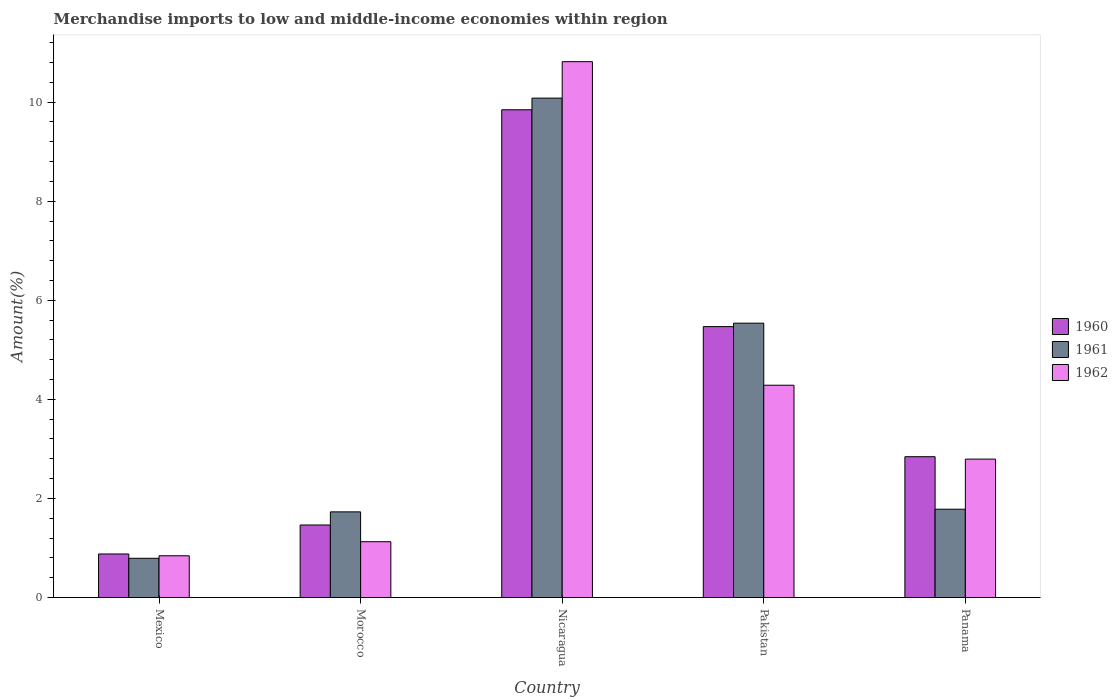How many different coloured bars are there?
Your answer should be very brief. 3. Are the number of bars per tick equal to the number of legend labels?
Offer a terse response. Yes. What is the label of the 1st group of bars from the left?
Provide a short and direct response. Mexico. In how many cases, is the number of bars for a given country not equal to the number of legend labels?
Keep it short and to the point. 0. What is the percentage of amount earned from merchandise imports in 1962 in Morocco?
Keep it short and to the point. 1.13. Across all countries, what is the maximum percentage of amount earned from merchandise imports in 1961?
Ensure brevity in your answer.  10.08. Across all countries, what is the minimum percentage of amount earned from merchandise imports in 1960?
Ensure brevity in your answer.  0.88. In which country was the percentage of amount earned from merchandise imports in 1960 maximum?
Your answer should be compact. Nicaragua. In which country was the percentage of amount earned from merchandise imports in 1962 minimum?
Offer a terse response. Mexico. What is the total percentage of amount earned from merchandise imports in 1962 in the graph?
Ensure brevity in your answer.  19.86. What is the difference between the percentage of amount earned from merchandise imports in 1961 in Morocco and that in Panama?
Keep it short and to the point. -0.05. What is the difference between the percentage of amount earned from merchandise imports in 1960 in Panama and the percentage of amount earned from merchandise imports in 1962 in Mexico?
Provide a short and direct response. 2. What is the average percentage of amount earned from merchandise imports in 1960 per country?
Keep it short and to the point. 4.1. What is the difference between the percentage of amount earned from merchandise imports of/in 1962 and percentage of amount earned from merchandise imports of/in 1960 in Mexico?
Provide a succinct answer. -0.04. What is the ratio of the percentage of amount earned from merchandise imports in 1961 in Nicaragua to that in Panama?
Ensure brevity in your answer.  5.66. What is the difference between the highest and the second highest percentage of amount earned from merchandise imports in 1961?
Keep it short and to the point. -8.3. What is the difference between the highest and the lowest percentage of amount earned from merchandise imports in 1961?
Make the answer very short. 9.29. In how many countries, is the percentage of amount earned from merchandise imports in 1961 greater than the average percentage of amount earned from merchandise imports in 1961 taken over all countries?
Provide a short and direct response. 2. Is the sum of the percentage of amount earned from merchandise imports in 1961 in Nicaragua and Pakistan greater than the maximum percentage of amount earned from merchandise imports in 1962 across all countries?
Your answer should be very brief. Yes. What does the 2nd bar from the left in Mexico represents?
Give a very brief answer. 1961. What does the 2nd bar from the right in Panama represents?
Your answer should be very brief. 1961. Does the graph contain any zero values?
Your response must be concise. No. Where does the legend appear in the graph?
Ensure brevity in your answer.  Center right. How many legend labels are there?
Keep it short and to the point. 3. How are the legend labels stacked?
Ensure brevity in your answer.  Vertical. What is the title of the graph?
Your answer should be compact. Merchandise imports to low and middle-income economies within region. What is the label or title of the X-axis?
Your answer should be compact. Country. What is the label or title of the Y-axis?
Provide a succinct answer. Amount(%). What is the Amount(%) in 1960 in Mexico?
Your answer should be very brief. 0.88. What is the Amount(%) of 1961 in Mexico?
Your response must be concise. 0.79. What is the Amount(%) in 1962 in Mexico?
Make the answer very short. 0.84. What is the Amount(%) in 1960 in Morocco?
Your answer should be compact. 1.46. What is the Amount(%) of 1961 in Morocco?
Give a very brief answer. 1.73. What is the Amount(%) in 1962 in Morocco?
Offer a terse response. 1.13. What is the Amount(%) in 1960 in Nicaragua?
Offer a very short reply. 9.85. What is the Amount(%) of 1961 in Nicaragua?
Offer a very short reply. 10.08. What is the Amount(%) in 1962 in Nicaragua?
Provide a succinct answer. 10.82. What is the Amount(%) of 1960 in Pakistan?
Keep it short and to the point. 5.47. What is the Amount(%) in 1961 in Pakistan?
Ensure brevity in your answer.  5.54. What is the Amount(%) in 1962 in Pakistan?
Provide a succinct answer. 4.29. What is the Amount(%) of 1960 in Panama?
Keep it short and to the point. 2.84. What is the Amount(%) in 1961 in Panama?
Offer a very short reply. 1.78. What is the Amount(%) of 1962 in Panama?
Your answer should be compact. 2.79. Across all countries, what is the maximum Amount(%) in 1960?
Your answer should be very brief. 9.85. Across all countries, what is the maximum Amount(%) in 1961?
Give a very brief answer. 10.08. Across all countries, what is the maximum Amount(%) of 1962?
Keep it short and to the point. 10.82. Across all countries, what is the minimum Amount(%) in 1960?
Your answer should be very brief. 0.88. Across all countries, what is the minimum Amount(%) of 1961?
Your response must be concise. 0.79. Across all countries, what is the minimum Amount(%) of 1962?
Offer a terse response. 0.84. What is the total Amount(%) of 1960 in the graph?
Provide a succinct answer. 20.5. What is the total Amount(%) in 1961 in the graph?
Make the answer very short. 19.92. What is the total Amount(%) of 1962 in the graph?
Offer a terse response. 19.86. What is the difference between the Amount(%) of 1960 in Mexico and that in Morocco?
Provide a succinct answer. -0.59. What is the difference between the Amount(%) of 1961 in Mexico and that in Morocco?
Offer a very short reply. -0.94. What is the difference between the Amount(%) in 1962 in Mexico and that in Morocco?
Ensure brevity in your answer.  -0.28. What is the difference between the Amount(%) of 1960 in Mexico and that in Nicaragua?
Your answer should be very brief. -8.97. What is the difference between the Amount(%) in 1961 in Mexico and that in Nicaragua?
Your answer should be very brief. -9.29. What is the difference between the Amount(%) of 1962 in Mexico and that in Nicaragua?
Provide a succinct answer. -9.97. What is the difference between the Amount(%) of 1960 in Mexico and that in Pakistan?
Give a very brief answer. -4.59. What is the difference between the Amount(%) in 1961 in Mexico and that in Pakistan?
Keep it short and to the point. -4.75. What is the difference between the Amount(%) in 1962 in Mexico and that in Pakistan?
Offer a terse response. -3.44. What is the difference between the Amount(%) in 1960 in Mexico and that in Panama?
Give a very brief answer. -1.96. What is the difference between the Amount(%) in 1961 in Mexico and that in Panama?
Your answer should be compact. -0.99. What is the difference between the Amount(%) of 1962 in Mexico and that in Panama?
Keep it short and to the point. -1.95. What is the difference between the Amount(%) of 1960 in Morocco and that in Nicaragua?
Make the answer very short. -8.38. What is the difference between the Amount(%) in 1961 in Morocco and that in Nicaragua?
Your response must be concise. -8.35. What is the difference between the Amount(%) in 1962 in Morocco and that in Nicaragua?
Provide a succinct answer. -9.69. What is the difference between the Amount(%) in 1960 in Morocco and that in Pakistan?
Offer a very short reply. -4. What is the difference between the Amount(%) in 1961 in Morocco and that in Pakistan?
Offer a very short reply. -3.81. What is the difference between the Amount(%) in 1962 in Morocco and that in Pakistan?
Your response must be concise. -3.16. What is the difference between the Amount(%) in 1960 in Morocco and that in Panama?
Give a very brief answer. -1.38. What is the difference between the Amount(%) in 1961 in Morocco and that in Panama?
Provide a short and direct response. -0.05. What is the difference between the Amount(%) of 1962 in Morocco and that in Panama?
Give a very brief answer. -1.67. What is the difference between the Amount(%) of 1960 in Nicaragua and that in Pakistan?
Offer a terse response. 4.38. What is the difference between the Amount(%) in 1961 in Nicaragua and that in Pakistan?
Provide a succinct answer. 4.54. What is the difference between the Amount(%) in 1962 in Nicaragua and that in Pakistan?
Your answer should be compact. 6.53. What is the difference between the Amount(%) of 1960 in Nicaragua and that in Panama?
Your answer should be very brief. 7. What is the difference between the Amount(%) of 1961 in Nicaragua and that in Panama?
Your answer should be compact. 8.3. What is the difference between the Amount(%) in 1962 in Nicaragua and that in Panama?
Provide a succinct answer. 8.02. What is the difference between the Amount(%) in 1960 in Pakistan and that in Panama?
Offer a very short reply. 2.63. What is the difference between the Amount(%) of 1961 in Pakistan and that in Panama?
Keep it short and to the point. 3.76. What is the difference between the Amount(%) in 1962 in Pakistan and that in Panama?
Offer a terse response. 1.49. What is the difference between the Amount(%) in 1960 in Mexico and the Amount(%) in 1961 in Morocco?
Your answer should be very brief. -0.85. What is the difference between the Amount(%) of 1960 in Mexico and the Amount(%) of 1962 in Morocco?
Provide a succinct answer. -0.25. What is the difference between the Amount(%) in 1961 in Mexico and the Amount(%) in 1962 in Morocco?
Your answer should be compact. -0.33. What is the difference between the Amount(%) in 1960 in Mexico and the Amount(%) in 1961 in Nicaragua?
Make the answer very short. -9.2. What is the difference between the Amount(%) of 1960 in Mexico and the Amount(%) of 1962 in Nicaragua?
Your answer should be very brief. -9.94. What is the difference between the Amount(%) in 1961 in Mexico and the Amount(%) in 1962 in Nicaragua?
Provide a short and direct response. -10.02. What is the difference between the Amount(%) in 1960 in Mexico and the Amount(%) in 1961 in Pakistan?
Provide a succinct answer. -4.66. What is the difference between the Amount(%) in 1960 in Mexico and the Amount(%) in 1962 in Pakistan?
Ensure brevity in your answer.  -3.41. What is the difference between the Amount(%) of 1961 in Mexico and the Amount(%) of 1962 in Pakistan?
Make the answer very short. -3.49. What is the difference between the Amount(%) of 1960 in Mexico and the Amount(%) of 1961 in Panama?
Make the answer very short. -0.9. What is the difference between the Amount(%) in 1960 in Mexico and the Amount(%) in 1962 in Panama?
Your answer should be very brief. -1.92. What is the difference between the Amount(%) in 1961 in Mexico and the Amount(%) in 1962 in Panama?
Give a very brief answer. -2. What is the difference between the Amount(%) in 1960 in Morocco and the Amount(%) in 1961 in Nicaragua?
Offer a terse response. -8.62. What is the difference between the Amount(%) in 1960 in Morocco and the Amount(%) in 1962 in Nicaragua?
Your answer should be compact. -9.35. What is the difference between the Amount(%) of 1961 in Morocco and the Amount(%) of 1962 in Nicaragua?
Offer a very short reply. -9.09. What is the difference between the Amount(%) of 1960 in Morocco and the Amount(%) of 1961 in Pakistan?
Your answer should be very brief. -4.07. What is the difference between the Amount(%) of 1960 in Morocco and the Amount(%) of 1962 in Pakistan?
Offer a very short reply. -2.82. What is the difference between the Amount(%) of 1961 in Morocco and the Amount(%) of 1962 in Pakistan?
Keep it short and to the point. -2.56. What is the difference between the Amount(%) of 1960 in Morocco and the Amount(%) of 1961 in Panama?
Offer a very short reply. -0.32. What is the difference between the Amount(%) in 1960 in Morocco and the Amount(%) in 1962 in Panama?
Offer a terse response. -1.33. What is the difference between the Amount(%) in 1961 in Morocco and the Amount(%) in 1962 in Panama?
Keep it short and to the point. -1.06. What is the difference between the Amount(%) of 1960 in Nicaragua and the Amount(%) of 1961 in Pakistan?
Your response must be concise. 4.31. What is the difference between the Amount(%) of 1960 in Nicaragua and the Amount(%) of 1962 in Pakistan?
Keep it short and to the point. 5.56. What is the difference between the Amount(%) of 1961 in Nicaragua and the Amount(%) of 1962 in Pakistan?
Ensure brevity in your answer.  5.8. What is the difference between the Amount(%) of 1960 in Nicaragua and the Amount(%) of 1961 in Panama?
Give a very brief answer. 8.06. What is the difference between the Amount(%) of 1960 in Nicaragua and the Amount(%) of 1962 in Panama?
Provide a succinct answer. 7.05. What is the difference between the Amount(%) in 1961 in Nicaragua and the Amount(%) in 1962 in Panama?
Ensure brevity in your answer.  7.29. What is the difference between the Amount(%) of 1960 in Pakistan and the Amount(%) of 1961 in Panama?
Ensure brevity in your answer.  3.69. What is the difference between the Amount(%) in 1960 in Pakistan and the Amount(%) in 1962 in Panama?
Give a very brief answer. 2.67. What is the difference between the Amount(%) in 1961 in Pakistan and the Amount(%) in 1962 in Panama?
Your answer should be compact. 2.74. What is the average Amount(%) in 1960 per country?
Provide a short and direct response. 4.1. What is the average Amount(%) in 1961 per country?
Make the answer very short. 3.98. What is the average Amount(%) of 1962 per country?
Provide a succinct answer. 3.97. What is the difference between the Amount(%) in 1960 and Amount(%) in 1961 in Mexico?
Your response must be concise. 0.09. What is the difference between the Amount(%) in 1960 and Amount(%) in 1962 in Mexico?
Offer a very short reply. 0.04. What is the difference between the Amount(%) in 1961 and Amount(%) in 1962 in Mexico?
Make the answer very short. -0.05. What is the difference between the Amount(%) in 1960 and Amount(%) in 1961 in Morocco?
Offer a very short reply. -0.27. What is the difference between the Amount(%) of 1960 and Amount(%) of 1962 in Morocco?
Your answer should be compact. 0.34. What is the difference between the Amount(%) of 1961 and Amount(%) of 1962 in Morocco?
Provide a short and direct response. 0.6. What is the difference between the Amount(%) of 1960 and Amount(%) of 1961 in Nicaragua?
Your answer should be compact. -0.24. What is the difference between the Amount(%) in 1960 and Amount(%) in 1962 in Nicaragua?
Ensure brevity in your answer.  -0.97. What is the difference between the Amount(%) of 1961 and Amount(%) of 1962 in Nicaragua?
Offer a terse response. -0.74. What is the difference between the Amount(%) in 1960 and Amount(%) in 1961 in Pakistan?
Your response must be concise. -0.07. What is the difference between the Amount(%) of 1960 and Amount(%) of 1962 in Pakistan?
Make the answer very short. 1.18. What is the difference between the Amount(%) of 1961 and Amount(%) of 1962 in Pakistan?
Offer a terse response. 1.25. What is the difference between the Amount(%) in 1960 and Amount(%) in 1961 in Panama?
Offer a very short reply. 1.06. What is the difference between the Amount(%) in 1960 and Amount(%) in 1962 in Panama?
Your answer should be compact. 0.05. What is the difference between the Amount(%) of 1961 and Amount(%) of 1962 in Panama?
Ensure brevity in your answer.  -1.01. What is the ratio of the Amount(%) in 1960 in Mexico to that in Morocco?
Make the answer very short. 0.6. What is the ratio of the Amount(%) of 1961 in Mexico to that in Morocco?
Offer a very short reply. 0.46. What is the ratio of the Amount(%) of 1962 in Mexico to that in Morocco?
Provide a short and direct response. 0.75. What is the ratio of the Amount(%) of 1960 in Mexico to that in Nicaragua?
Ensure brevity in your answer.  0.09. What is the ratio of the Amount(%) of 1961 in Mexico to that in Nicaragua?
Make the answer very short. 0.08. What is the ratio of the Amount(%) of 1962 in Mexico to that in Nicaragua?
Give a very brief answer. 0.08. What is the ratio of the Amount(%) of 1960 in Mexico to that in Pakistan?
Your answer should be compact. 0.16. What is the ratio of the Amount(%) of 1961 in Mexico to that in Pakistan?
Provide a short and direct response. 0.14. What is the ratio of the Amount(%) of 1962 in Mexico to that in Pakistan?
Provide a succinct answer. 0.2. What is the ratio of the Amount(%) of 1960 in Mexico to that in Panama?
Your answer should be very brief. 0.31. What is the ratio of the Amount(%) in 1961 in Mexico to that in Panama?
Your answer should be compact. 0.44. What is the ratio of the Amount(%) of 1962 in Mexico to that in Panama?
Give a very brief answer. 0.3. What is the ratio of the Amount(%) of 1960 in Morocco to that in Nicaragua?
Offer a very short reply. 0.15. What is the ratio of the Amount(%) in 1961 in Morocco to that in Nicaragua?
Provide a succinct answer. 0.17. What is the ratio of the Amount(%) in 1962 in Morocco to that in Nicaragua?
Your response must be concise. 0.1. What is the ratio of the Amount(%) in 1960 in Morocco to that in Pakistan?
Your answer should be very brief. 0.27. What is the ratio of the Amount(%) in 1961 in Morocco to that in Pakistan?
Give a very brief answer. 0.31. What is the ratio of the Amount(%) of 1962 in Morocco to that in Pakistan?
Your response must be concise. 0.26. What is the ratio of the Amount(%) of 1960 in Morocco to that in Panama?
Make the answer very short. 0.52. What is the ratio of the Amount(%) in 1961 in Morocco to that in Panama?
Your answer should be very brief. 0.97. What is the ratio of the Amount(%) of 1962 in Morocco to that in Panama?
Give a very brief answer. 0.4. What is the ratio of the Amount(%) of 1960 in Nicaragua to that in Pakistan?
Your answer should be compact. 1.8. What is the ratio of the Amount(%) in 1961 in Nicaragua to that in Pakistan?
Your response must be concise. 1.82. What is the ratio of the Amount(%) in 1962 in Nicaragua to that in Pakistan?
Keep it short and to the point. 2.52. What is the ratio of the Amount(%) of 1960 in Nicaragua to that in Panama?
Your answer should be very brief. 3.46. What is the ratio of the Amount(%) in 1961 in Nicaragua to that in Panama?
Your response must be concise. 5.66. What is the ratio of the Amount(%) in 1962 in Nicaragua to that in Panama?
Keep it short and to the point. 3.87. What is the ratio of the Amount(%) of 1960 in Pakistan to that in Panama?
Provide a succinct answer. 1.92. What is the ratio of the Amount(%) of 1961 in Pakistan to that in Panama?
Your answer should be compact. 3.11. What is the ratio of the Amount(%) of 1962 in Pakistan to that in Panama?
Your response must be concise. 1.53. What is the difference between the highest and the second highest Amount(%) in 1960?
Make the answer very short. 4.38. What is the difference between the highest and the second highest Amount(%) in 1961?
Offer a very short reply. 4.54. What is the difference between the highest and the second highest Amount(%) in 1962?
Provide a succinct answer. 6.53. What is the difference between the highest and the lowest Amount(%) in 1960?
Give a very brief answer. 8.97. What is the difference between the highest and the lowest Amount(%) in 1961?
Your response must be concise. 9.29. What is the difference between the highest and the lowest Amount(%) of 1962?
Your response must be concise. 9.97. 